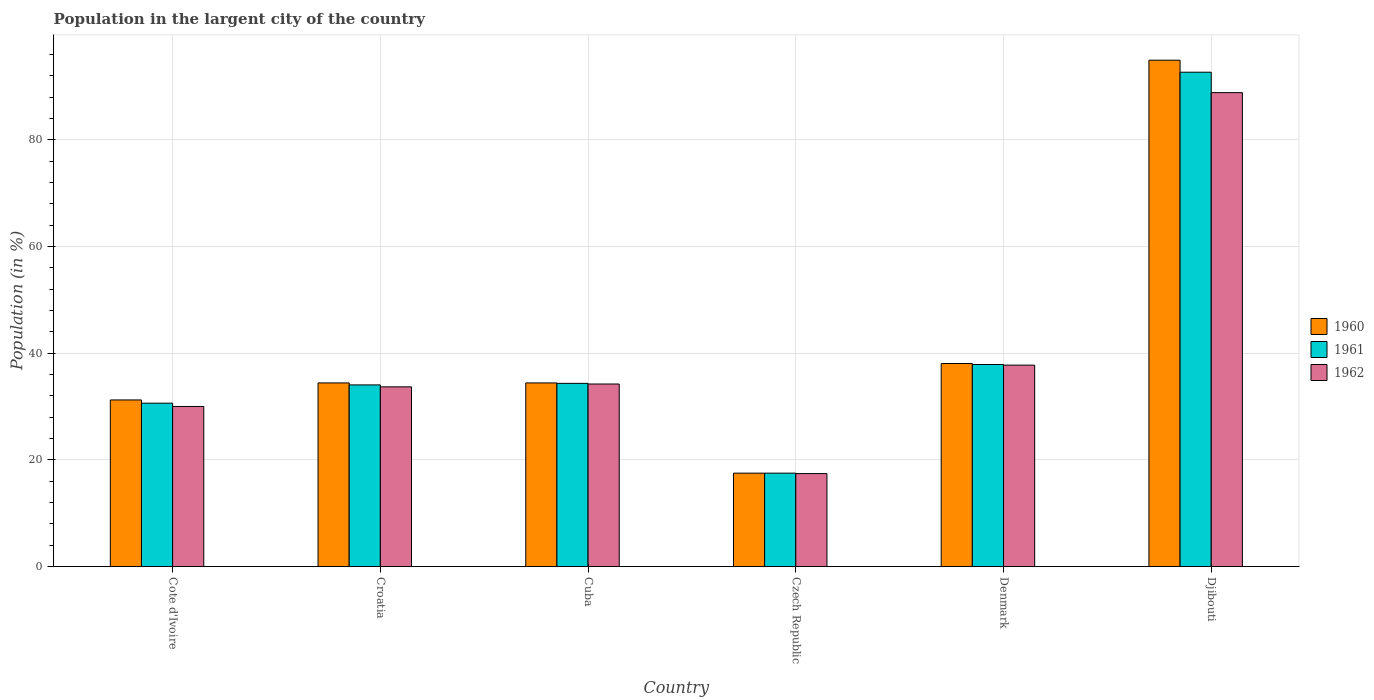How many groups of bars are there?
Offer a very short reply. 6. What is the label of the 3rd group of bars from the left?
Give a very brief answer. Cuba. In how many cases, is the number of bars for a given country not equal to the number of legend labels?
Make the answer very short. 0. What is the percentage of population in the largent city in 1962 in Cuba?
Provide a short and direct response. 34.22. Across all countries, what is the maximum percentage of population in the largent city in 1961?
Provide a short and direct response. 92.69. Across all countries, what is the minimum percentage of population in the largent city in 1961?
Ensure brevity in your answer.  17.5. In which country was the percentage of population in the largent city in 1960 maximum?
Offer a very short reply. Djibouti. In which country was the percentage of population in the largent city in 1962 minimum?
Provide a short and direct response. Czech Republic. What is the total percentage of population in the largent city in 1961 in the graph?
Offer a terse response. 247.08. What is the difference between the percentage of population in the largent city in 1961 in Czech Republic and that in Denmark?
Offer a terse response. -20.38. What is the difference between the percentage of population in the largent city in 1962 in Croatia and the percentage of population in the largent city in 1961 in Cuba?
Offer a terse response. -0.65. What is the average percentage of population in the largent city in 1961 per country?
Make the answer very short. 41.18. What is the difference between the percentage of population in the largent city of/in 1960 and percentage of population in the largent city of/in 1962 in Cote d'Ivoire?
Your response must be concise. 1.22. In how many countries, is the percentage of population in the largent city in 1960 greater than 48 %?
Your answer should be very brief. 1. What is the ratio of the percentage of population in the largent city in 1961 in Czech Republic to that in Djibouti?
Your answer should be very brief. 0.19. What is the difference between the highest and the second highest percentage of population in the largent city in 1960?
Ensure brevity in your answer.  3.64. What is the difference between the highest and the lowest percentage of population in the largent city in 1960?
Make the answer very short. 77.44. In how many countries, is the percentage of population in the largent city in 1961 greater than the average percentage of population in the largent city in 1961 taken over all countries?
Offer a very short reply. 1. Are all the bars in the graph horizontal?
Offer a terse response. No. What is the difference between two consecutive major ticks on the Y-axis?
Offer a terse response. 20. Does the graph contain any zero values?
Provide a short and direct response. No. Does the graph contain grids?
Provide a succinct answer. Yes. How many legend labels are there?
Offer a terse response. 3. How are the legend labels stacked?
Make the answer very short. Vertical. What is the title of the graph?
Provide a short and direct response. Population in the largent city of the country. What is the label or title of the X-axis?
Make the answer very short. Country. What is the Population (in %) of 1960 in Cote d'Ivoire?
Offer a terse response. 31.23. What is the Population (in %) of 1961 in Cote d'Ivoire?
Your answer should be very brief. 30.62. What is the Population (in %) of 1962 in Cote d'Ivoire?
Your answer should be very brief. 30.01. What is the Population (in %) of 1960 in Croatia?
Your response must be concise. 34.42. What is the Population (in %) in 1961 in Croatia?
Ensure brevity in your answer.  34.05. What is the Population (in %) of 1962 in Croatia?
Offer a very short reply. 33.69. What is the Population (in %) in 1960 in Cuba?
Provide a short and direct response. 34.42. What is the Population (in %) in 1961 in Cuba?
Offer a terse response. 34.34. What is the Population (in %) in 1962 in Cuba?
Ensure brevity in your answer.  34.22. What is the Population (in %) in 1960 in Czech Republic?
Your response must be concise. 17.5. What is the Population (in %) in 1961 in Czech Republic?
Make the answer very short. 17.5. What is the Population (in %) of 1962 in Czech Republic?
Your answer should be compact. 17.42. What is the Population (in %) of 1960 in Denmark?
Your answer should be compact. 38.06. What is the Population (in %) in 1961 in Denmark?
Offer a very short reply. 37.88. What is the Population (in %) in 1962 in Denmark?
Provide a succinct answer. 37.76. What is the Population (in %) in 1960 in Djibouti?
Your response must be concise. 94.94. What is the Population (in %) in 1961 in Djibouti?
Provide a short and direct response. 92.69. What is the Population (in %) in 1962 in Djibouti?
Your response must be concise. 88.86. Across all countries, what is the maximum Population (in %) of 1960?
Ensure brevity in your answer.  94.94. Across all countries, what is the maximum Population (in %) of 1961?
Provide a succinct answer. 92.69. Across all countries, what is the maximum Population (in %) in 1962?
Ensure brevity in your answer.  88.86. Across all countries, what is the minimum Population (in %) of 1960?
Provide a short and direct response. 17.5. Across all countries, what is the minimum Population (in %) in 1961?
Your answer should be compact. 17.5. Across all countries, what is the minimum Population (in %) in 1962?
Make the answer very short. 17.42. What is the total Population (in %) of 1960 in the graph?
Offer a very short reply. 250.58. What is the total Population (in %) in 1961 in the graph?
Give a very brief answer. 247.08. What is the total Population (in %) of 1962 in the graph?
Offer a very short reply. 241.95. What is the difference between the Population (in %) of 1960 in Cote d'Ivoire and that in Croatia?
Provide a short and direct response. -3.19. What is the difference between the Population (in %) in 1961 in Cote d'Ivoire and that in Croatia?
Your answer should be very brief. -3.43. What is the difference between the Population (in %) in 1962 in Cote d'Ivoire and that in Croatia?
Provide a succinct answer. -3.68. What is the difference between the Population (in %) in 1960 in Cote d'Ivoire and that in Cuba?
Offer a terse response. -3.19. What is the difference between the Population (in %) of 1961 in Cote d'Ivoire and that in Cuba?
Provide a short and direct response. -3.72. What is the difference between the Population (in %) of 1962 in Cote d'Ivoire and that in Cuba?
Keep it short and to the point. -4.21. What is the difference between the Population (in %) of 1960 in Cote d'Ivoire and that in Czech Republic?
Provide a succinct answer. 13.73. What is the difference between the Population (in %) in 1961 in Cote d'Ivoire and that in Czech Republic?
Offer a terse response. 13.12. What is the difference between the Population (in %) of 1962 in Cote d'Ivoire and that in Czech Republic?
Offer a terse response. 12.59. What is the difference between the Population (in %) of 1960 in Cote d'Ivoire and that in Denmark?
Give a very brief answer. -6.83. What is the difference between the Population (in %) in 1961 in Cote d'Ivoire and that in Denmark?
Offer a very short reply. -7.25. What is the difference between the Population (in %) in 1962 in Cote d'Ivoire and that in Denmark?
Ensure brevity in your answer.  -7.75. What is the difference between the Population (in %) of 1960 in Cote d'Ivoire and that in Djibouti?
Offer a very short reply. -63.71. What is the difference between the Population (in %) of 1961 in Cote d'Ivoire and that in Djibouti?
Your answer should be very brief. -62.07. What is the difference between the Population (in %) of 1962 in Cote d'Ivoire and that in Djibouti?
Offer a very short reply. -58.85. What is the difference between the Population (in %) in 1960 in Croatia and that in Cuba?
Ensure brevity in your answer.  0. What is the difference between the Population (in %) of 1961 in Croatia and that in Cuba?
Offer a terse response. -0.29. What is the difference between the Population (in %) of 1962 in Croatia and that in Cuba?
Provide a short and direct response. -0.53. What is the difference between the Population (in %) of 1960 in Croatia and that in Czech Republic?
Keep it short and to the point. 16.92. What is the difference between the Population (in %) in 1961 in Croatia and that in Czech Republic?
Give a very brief answer. 16.55. What is the difference between the Population (in %) in 1962 in Croatia and that in Czech Republic?
Provide a succinct answer. 16.27. What is the difference between the Population (in %) in 1960 in Croatia and that in Denmark?
Provide a succinct answer. -3.64. What is the difference between the Population (in %) in 1961 in Croatia and that in Denmark?
Your answer should be compact. -3.83. What is the difference between the Population (in %) in 1962 in Croatia and that in Denmark?
Keep it short and to the point. -4.07. What is the difference between the Population (in %) in 1960 in Croatia and that in Djibouti?
Keep it short and to the point. -60.52. What is the difference between the Population (in %) in 1961 in Croatia and that in Djibouti?
Ensure brevity in your answer.  -58.64. What is the difference between the Population (in %) in 1962 in Croatia and that in Djibouti?
Your answer should be compact. -55.18. What is the difference between the Population (in %) of 1960 in Cuba and that in Czech Republic?
Give a very brief answer. 16.92. What is the difference between the Population (in %) in 1961 in Cuba and that in Czech Republic?
Keep it short and to the point. 16.84. What is the difference between the Population (in %) of 1962 in Cuba and that in Czech Republic?
Make the answer very short. 16.8. What is the difference between the Population (in %) of 1960 in Cuba and that in Denmark?
Ensure brevity in your answer.  -3.64. What is the difference between the Population (in %) in 1961 in Cuba and that in Denmark?
Your answer should be very brief. -3.54. What is the difference between the Population (in %) of 1962 in Cuba and that in Denmark?
Offer a terse response. -3.54. What is the difference between the Population (in %) in 1960 in Cuba and that in Djibouti?
Make the answer very short. -60.52. What is the difference between the Population (in %) in 1961 in Cuba and that in Djibouti?
Make the answer very short. -58.35. What is the difference between the Population (in %) of 1962 in Cuba and that in Djibouti?
Your answer should be very brief. -54.64. What is the difference between the Population (in %) in 1960 in Czech Republic and that in Denmark?
Make the answer very short. -20.56. What is the difference between the Population (in %) in 1961 in Czech Republic and that in Denmark?
Your response must be concise. -20.38. What is the difference between the Population (in %) of 1962 in Czech Republic and that in Denmark?
Offer a terse response. -20.34. What is the difference between the Population (in %) in 1960 in Czech Republic and that in Djibouti?
Your answer should be very brief. -77.44. What is the difference between the Population (in %) of 1961 in Czech Republic and that in Djibouti?
Provide a short and direct response. -75.19. What is the difference between the Population (in %) in 1962 in Czech Republic and that in Djibouti?
Keep it short and to the point. -71.44. What is the difference between the Population (in %) of 1960 in Denmark and that in Djibouti?
Your answer should be compact. -56.88. What is the difference between the Population (in %) in 1961 in Denmark and that in Djibouti?
Offer a terse response. -54.81. What is the difference between the Population (in %) of 1962 in Denmark and that in Djibouti?
Make the answer very short. -51.1. What is the difference between the Population (in %) of 1960 in Cote d'Ivoire and the Population (in %) of 1961 in Croatia?
Your answer should be very brief. -2.82. What is the difference between the Population (in %) in 1960 in Cote d'Ivoire and the Population (in %) in 1962 in Croatia?
Make the answer very short. -2.45. What is the difference between the Population (in %) of 1961 in Cote d'Ivoire and the Population (in %) of 1962 in Croatia?
Keep it short and to the point. -3.06. What is the difference between the Population (in %) of 1960 in Cote d'Ivoire and the Population (in %) of 1961 in Cuba?
Ensure brevity in your answer.  -3.11. What is the difference between the Population (in %) in 1960 in Cote d'Ivoire and the Population (in %) in 1962 in Cuba?
Your response must be concise. -2.99. What is the difference between the Population (in %) of 1961 in Cote d'Ivoire and the Population (in %) of 1962 in Cuba?
Make the answer very short. -3.6. What is the difference between the Population (in %) of 1960 in Cote d'Ivoire and the Population (in %) of 1961 in Czech Republic?
Provide a succinct answer. 13.73. What is the difference between the Population (in %) in 1960 in Cote d'Ivoire and the Population (in %) in 1962 in Czech Republic?
Offer a terse response. 13.81. What is the difference between the Population (in %) of 1961 in Cote d'Ivoire and the Population (in %) of 1962 in Czech Republic?
Your answer should be very brief. 13.21. What is the difference between the Population (in %) of 1960 in Cote d'Ivoire and the Population (in %) of 1961 in Denmark?
Make the answer very short. -6.65. What is the difference between the Population (in %) of 1960 in Cote d'Ivoire and the Population (in %) of 1962 in Denmark?
Provide a short and direct response. -6.53. What is the difference between the Population (in %) in 1961 in Cote d'Ivoire and the Population (in %) in 1962 in Denmark?
Give a very brief answer. -7.14. What is the difference between the Population (in %) of 1960 in Cote d'Ivoire and the Population (in %) of 1961 in Djibouti?
Offer a very short reply. -61.46. What is the difference between the Population (in %) in 1960 in Cote d'Ivoire and the Population (in %) in 1962 in Djibouti?
Provide a succinct answer. -57.63. What is the difference between the Population (in %) in 1961 in Cote d'Ivoire and the Population (in %) in 1962 in Djibouti?
Make the answer very short. -58.24. What is the difference between the Population (in %) in 1960 in Croatia and the Population (in %) in 1961 in Cuba?
Give a very brief answer. 0.08. What is the difference between the Population (in %) of 1960 in Croatia and the Population (in %) of 1962 in Cuba?
Keep it short and to the point. 0.2. What is the difference between the Population (in %) of 1961 in Croatia and the Population (in %) of 1962 in Cuba?
Offer a terse response. -0.17. What is the difference between the Population (in %) of 1960 in Croatia and the Population (in %) of 1961 in Czech Republic?
Your answer should be compact. 16.92. What is the difference between the Population (in %) in 1960 in Croatia and the Population (in %) in 1962 in Czech Republic?
Your response must be concise. 17. What is the difference between the Population (in %) of 1961 in Croatia and the Population (in %) of 1962 in Czech Republic?
Offer a terse response. 16.63. What is the difference between the Population (in %) in 1960 in Croatia and the Population (in %) in 1961 in Denmark?
Make the answer very short. -3.46. What is the difference between the Population (in %) of 1960 in Croatia and the Population (in %) of 1962 in Denmark?
Keep it short and to the point. -3.34. What is the difference between the Population (in %) of 1961 in Croatia and the Population (in %) of 1962 in Denmark?
Your answer should be compact. -3.71. What is the difference between the Population (in %) in 1960 in Croatia and the Population (in %) in 1961 in Djibouti?
Make the answer very short. -58.27. What is the difference between the Population (in %) in 1960 in Croatia and the Population (in %) in 1962 in Djibouti?
Make the answer very short. -54.44. What is the difference between the Population (in %) in 1961 in Croatia and the Population (in %) in 1962 in Djibouti?
Provide a succinct answer. -54.81. What is the difference between the Population (in %) in 1960 in Cuba and the Population (in %) in 1961 in Czech Republic?
Ensure brevity in your answer.  16.92. What is the difference between the Population (in %) of 1960 in Cuba and the Population (in %) of 1962 in Czech Republic?
Keep it short and to the point. 17. What is the difference between the Population (in %) in 1961 in Cuba and the Population (in %) in 1962 in Czech Republic?
Provide a succinct answer. 16.92. What is the difference between the Population (in %) in 1960 in Cuba and the Population (in %) in 1961 in Denmark?
Provide a short and direct response. -3.46. What is the difference between the Population (in %) of 1960 in Cuba and the Population (in %) of 1962 in Denmark?
Your response must be concise. -3.34. What is the difference between the Population (in %) of 1961 in Cuba and the Population (in %) of 1962 in Denmark?
Make the answer very short. -3.42. What is the difference between the Population (in %) of 1960 in Cuba and the Population (in %) of 1961 in Djibouti?
Provide a succinct answer. -58.27. What is the difference between the Population (in %) in 1960 in Cuba and the Population (in %) in 1962 in Djibouti?
Keep it short and to the point. -54.44. What is the difference between the Population (in %) in 1961 in Cuba and the Population (in %) in 1962 in Djibouti?
Your response must be concise. -54.52. What is the difference between the Population (in %) in 1960 in Czech Republic and the Population (in %) in 1961 in Denmark?
Your response must be concise. -20.37. What is the difference between the Population (in %) in 1960 in Czech Republic and the Population (in %) in 1962 in Denmark?
Provide a short and direct response. -20.26. What is the difference between the Population (in %) in 1961 in Czech Republic and the Population (in %) in 1962 in Denmark?
Make the answer very short. -20.26. What is the difference between the Population (in %) of 1960 in Czech Republic and the Population (in %) of 1961 in Djibouti?
Provide a succinct answer. -75.19. What is the difference between the Population (in %) in 1960 in Czech Republic and the Population (in %) in 1962 in Djibouti?
Your response must be concise. -71.36. What is the difference between the Population (in %) in 1961 in Czech Republic and the Population (in %) in 1962 in Djibouti?
Ensure brevity in your answer.  -71.36. What is the difference between the Population (in %) in 1960 in Denmark and the Population (in %) in 1961 in Djibouti?
Make the answer very short. -54.63. What is the difference between the Population (in %) in 1960 in Denmark and the Population (in %) in 1962 in Djibouti?
Keep it short and to the point. -50.8. What is the difference between the Population (in %) of 1961 in Denmark and the Population (in %) of 1962 in Djibouti?
Make the answer very short. -50.98. What is the average Population (in %) of 1960 per country?
Your response must be concise. 41.76. What is the average Population (in %) of 1961 per country?
Your response must be concise. 41.18. What is the average Population (in %) of 1962 per country?
Your answer should be compact. 40.33. What is the difference between the Population (in %) in 1960 and Population (in %) in 1961 in Cote d'Ivoire?
Your response must be concise. 0.61. What is the difference between the Population (in %) of 1960 and Population (in %) of 1962 in Cote d'Ivoire?
Make the answer very short. 1.22. What is the difference between the Population (in %) of 1961 and Population (in %) of 1962 in Cote d'Ivoire?
Your answer should be compact. 0.61. What is the difference between the Population (in %) in 1960 and Population (in %) in 1961 in Croatia?
Provide a short and direct response. 0.37. What is the difference between the Population (in %) in 1960 and Population (in %) in 1962 in Croatia?
Your answer should be very brief. 0.74. What is the difference between the Population (in %) of 1961 and Population (in %) of 1962 in Croatia?
Offer a very short reply. 0.36. What is the difference between the Population (in %) of 1960 and Population (in %) of 1961 in Cuba?
Ensure brevity in your answer.  0.08. What is the difference between the Population (in %) in 1960 and Population (in %) in 1962 in Cuba?
Provide a short and direct response. 0.2. What is the difference between the Population (in %) in 1961 and Population (in %) in 1962 in Cuba?
Your answer should be compact. 0.12. What is the difference between the Population (in %) of 1960 and Population (in %) of 1961 in Czech Republic?
Your response must be concise. 0. What is the difference between the Population (in %) in 1960 and Population (in %) in 1962 in Czech Republic?
Your response must be concise. 0.08. What is the difference between the Population (in %) of 1961 and Population (in %) of 1962 in Czech Republic?
Provide a short and direct response. 0.08. What is the difference between the Population (in %) of 1960 and Population (in %) of 1961 in Denmark?
Make the answer very short. 0.18. What is the difference between the Population (in %) in 1960 and Population (in %) in 1962 in Denmark?
Your response must be concise. 0.3. What is the difference between the Population (in %) in 1961 and Population (in %) in 1962 in Denmark?
Keep it short and to the point. 0.12. What is the difference between the Population (in %) in 1960 and Population (in %) in 1961 in Djibouti?
Provide a succinct answer. 2.25. What is the difference between the Population (in %) in 1960 and Population (in %) in 1962 in Djibouti?
Provide a succinct answer. 6.08. What is the difference between the Population (in %) in 1961 and Population (in %) in 1962 in Djibouti?
Your answer should be very brief. 3.83. What is the ratio of the Population (in %) of 1960 in Cote d'Ivoire to that in Croatia?
Give a very brief answer. 0.91. What is the ratio of the Population (in %) in 1961 in Cote d'Ivoire to that in Croatia?
Give a very brief answer. 0.9. What is the ratio of the Population (in %) in 1962 in Cote d'Ivoire to that in Croatia?
Offer a very short reply. 0.89. What is the ratio of the Population (in %) of 1960 in Cote d'Ivoire to that in Cuba?
Offer a very short reply. 0.91. What is the ratio of the Population (in %) of 1961 in Cote d'Ivoire to that in Cuba?
Provide a succinct answer. 0.89. What is the ratio of the Population (in %) in 1962 in Cote d'Ivoire to that in Cuba?
Ensure brevity in your answer.  0.88. What is the ratio of the Population (in %) in 1960 in Cote d'Ivoire to that in Czech Republic?
Your answer should be compact. 1.78. What is the ratio of the Population (in %) in 1961 in Cote d'Ivoire to that in Czech Republic?
Offer a very short reply. 1.75. What is the ratio of the Population (in %) in 1962 in Cote d'Ivoire to that in Czech Republic?
Make the answer very short. 1.72. What is the ratio of the Population (in %) of 1960 in Cote d'Ivoire to that in Denmark?
Give a very brief answer. 0.82. What is the ratio of the Population (in %) of 1961 in Cote d'Ivoire to that in Denmark?
Give a very brief answer. 0.81. What is the ratio of the Population (in %) in 1962 in Cote d'Ivoire to that in Denmark?
Ensure brevity in your answer.  0.79. What is the ratio of the Population (in %) in 1960 in Cote d'Ivoire to that in Djibouti?
Offer a very short reply. 0.33. What is the ratio of the Population (in %) in 1961 in Cote d'Ivoire to that in Djibouti?
Provide a succinct answer. 0.33. What is the ratio of the Population (in %) in 1962 in Cote d'Ivoire to that in Djibouti?
Offer a terse response. 0.34. What is the ratio of the Population (in %) of 1962 in Croatia to that in Cuba?
Keep it short and to the point. 0.98. What is the ratio of the Population (in %) of 1960 in Croatia to that in Czech Republic?
Provide a short and direct response. 1.97. What is the ratio of the Population (in %) of 1961 in Croatia to that in Czech Republic?
Make the answer very short. 1.95. What is the ratio of the Population (in %) in 1962 in Croatia to that in Czech Republic?
Offer a very short reply. 1.93. What is the ratio of the Population (in %) in 1960 in Croatia to that in Denmark?
Ensure brevity in your answer.  0.9. What is the ratio of the Population (in %) of 1961 in Croatia to that in Denmark?
Provide a succinct answer. 0.9. What is the ratio of the Population (in %) of 1962 in Croatia to that in Denmark?
Keep it short and to the point. 0.89. What is the ratio of the Population (in %) in 1960 in Croatia to that in Djibouti?
Provide a short and direct response. 0.36. What is the ratio of the Population (in %) in 1961 in Croatia to that in Djibouti?
Your answer should be compact. 0.37. What is the ratio of the Population (in %) of 1962 in Croatia to that in Djibouti?
Your response must be concise. 0.38. What is the ratio of the Population (in %) in 1960 in Cuba to that in Czech Republic?
Provide a short and direct response. 1.97. What is the ratio of the Population (in %) of 1961 in Cuba to that in Czech Republic?
Offer a terse response. 1.96. What is the ratio of the Population (in %) in 1962 in Cuba to that in Czech Republic?
Keep it short and to the point. 1.96. What is the ratio of the Population (in %) in 1960 in Cuba to that in Denmark?
Ensure brevity in your answer.  0.9. What is the ratio of the Population (in %) of 1961 in Cuba to that in Denmark?
Keep it short and to the point. 0.91. What is the ratio of the Population (in %) of 1962 in Cuba to that in Denmark?
Keep it short and to the point. 0.91. What is the ratio of the Population (in %) of 1960 in Cuba to that in Djibouti?
Your answer should be very brief. 0.36. What is the ratio of the Population (in %) of 1961 in Cuba to that in Djibouti?
Provide a short and direct response. 0.37. What is the ratio of the Population (in %) of 1962 in Cuba to that in Djibouti?
Make the answer very short. 0.39. What is the ratio of the Population (in %) in 1960 in Czech Republic to that in Denmark?
Your response must be concise. 0.46. What is the ratio of the Population (in %) in 1961 in Czech Republic to that in Denmark?
Keep it short and to the point. 0.46. What is the ratio of the Population (in %) in 1962 in Czech Republic to that in Denmark?
Provide a short and direct response. 0.46. What is the ratio of the Population (in %) in 1960 in Czech Republic to that in Djibouti?
Your response must be concise. 0.18. What is the ratio of the Population (in %) in 1961 in Czech Republic to that in Djibouti?
Ensure brevity in your answer.  0.19. What is the ratio of the Population (in %) of 1962 in Czech Republic to that in Djibouti?
Offer a very short reply. 0.2. What is the ratio of the Population (in %) in 1960 in Denmark to that in Djibouti?
Give a very brief answer. 0.4. What is the ratio of the Population (in %) of 1961 in Denmark to that in Djibouti?
Provide a short and direct response. 0.41. What is the ratio of the Population (in %) in 1962 in Denmark to that in Djibouti?
Ensure brevity in your answer.  0.42. What is the difference between the highest and the second highest Population (in %) in 1960?
Keep it short and to the point. 56.88. What is the difference between the highest and the second highest Population (in %) in 1961?
Your answer should be very brief. 54.81. What is the difference between the highest and the second highest Population (in %) in 1962?
Your response must be concise. 51.1. What is the difference between the highest and the lowest Population (in %) of 1960?
Ensure brevity in your answer.  77.44. What is the difference between the highest and the lowest Population (in %) in 1961?
Keep it short and to the point. 75.19. What is the difference between the highest and the lowest Population (in %) of 1962?
Ensure brevity in your answer.  71.44. 